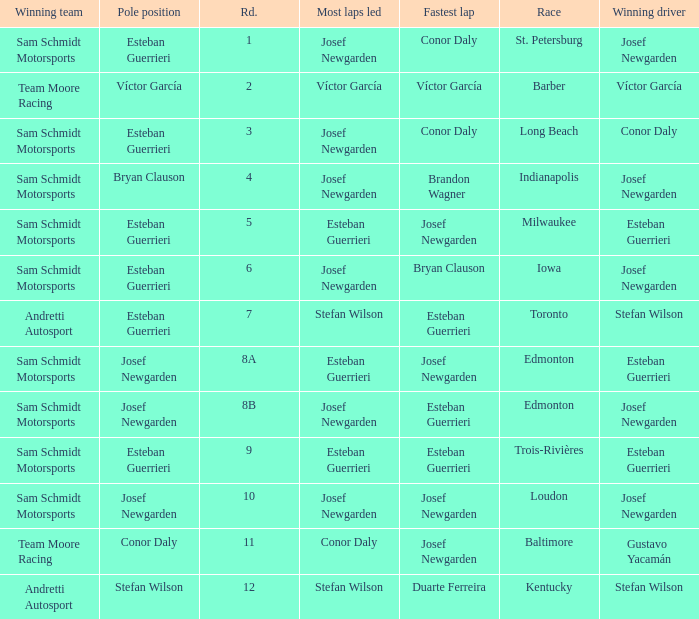Who had the fastest lap(s) when stefan wilson had the pole? Duarte Ferreira. 